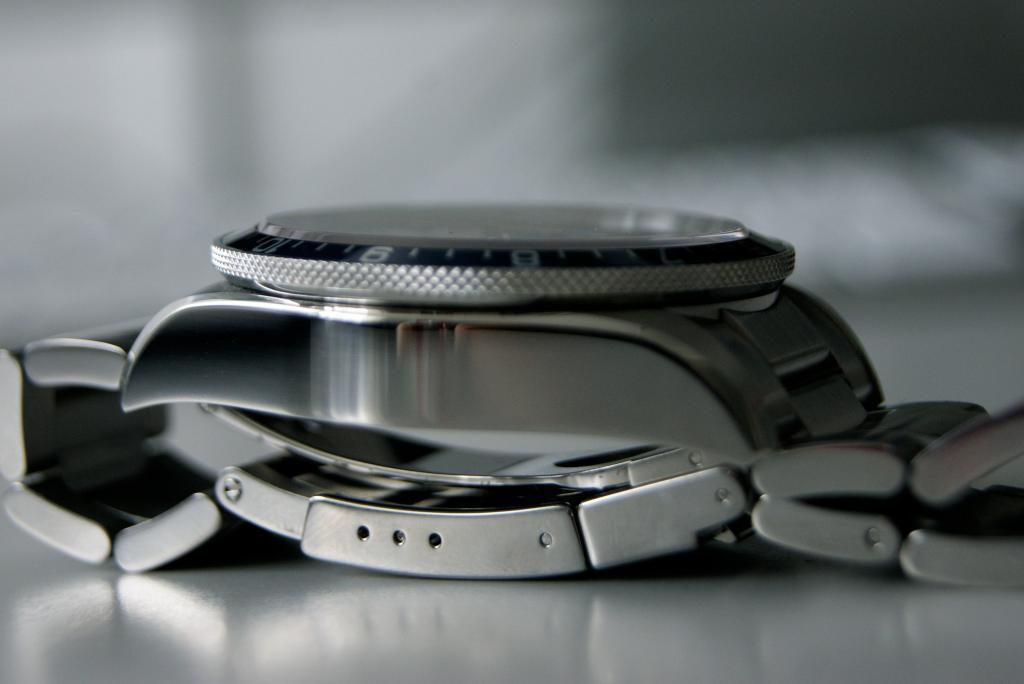How would you summarize this image in a sentence or two? In this image we can see a watch. There is a blur background. 